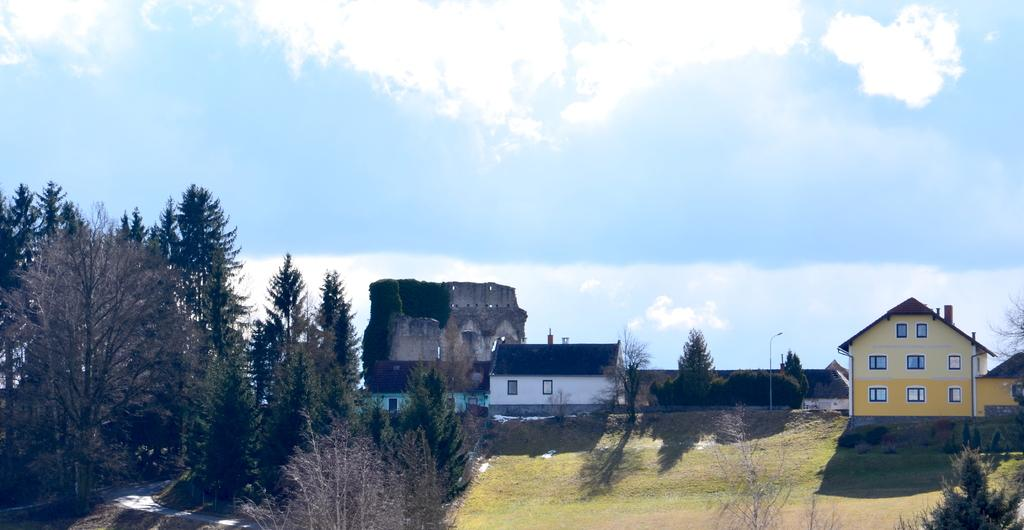What type of structures can be seen in the image? There are houses in the image. What feature is common to many of the houses? There are windows visible in the image. What is the purpose of the light pole in the image? The light pole provides illumination in the area. What type of vegetation can be seen in the image? There are plants and trees in the image. What part of the natural environment is visible in the image? The sky is visible in the image. What type of blood can be seen dripping from the engine in the image? There is no engine or blood present in the image. How many ducks are visible in the image? There are no ducks present in the image. 